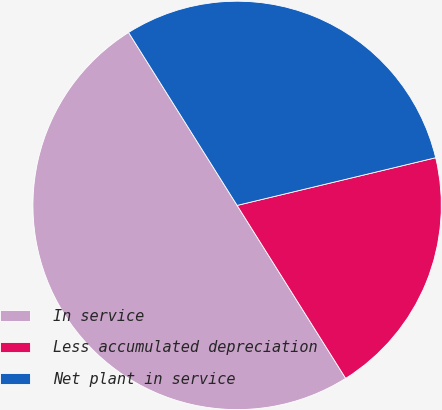Convert chart to OTSL. <chart><loc_0><loc_0><loc_500><loc_500><pie_chart><fcel>In service<fcel>Less accumulated depreciation<fcel>Net plant in service<nl><fcel>50.0%<fcel>19.83%<fcel>30.17%<nl></chart> 